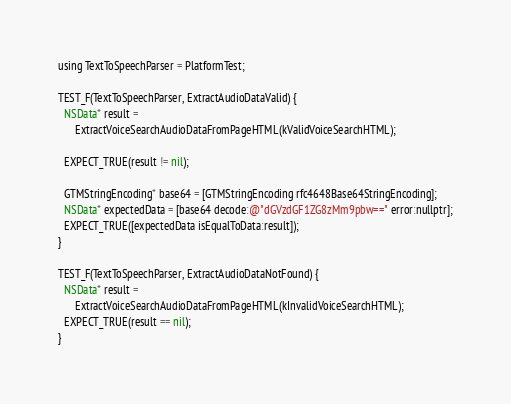Convert code to text. <code><loc_0><loc_0><loc_500><loc_500><_ObjectiveC_>using TextToSpeechParser = PlatformTest;

TEST_F(TextToSpeechParser, ExtractAudioDataValid) {
  NSData* result =
      ExtractVoiceSearchAudioDataFromPageHTML(kValidVoiceSearchHTML);

  EXPECT_TRUE(result != nil);

  GTMStringEncoding* base64 = [GTMStringEncoding rfc4648Base64StringEncoding];
  NSData* expectedData = [base64 decode:@"dGVzdGF1ZG8zMm9pbw==" error:nullptr];
  EXPECT_TRUE([expectedData isEqualToData:result]);
}

TEST_F(TextToSpeechParser, ExtractAudioDataNotFound) {
  NSData* result =
      ExtractVoiceSearchAudioDataFromPageHTML(kInvalidVoiceSearchHTML);
  EXPECT_TRUE(result == nil);
}
</code> 